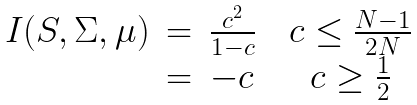Convert formula to latex. <formula><loc_0><loc_0><loc_500><loc_500>\begin{array} { c c c c c } I ( S , \Sigma , \mu ) & = & \frac { c ^ { 2 } } { 1 - c } & & c \leq \frac { N - 1 } { 2 N } \\ & = & - c & & c \geq \frac { 1 } { 2 } \end{array}</formula> 